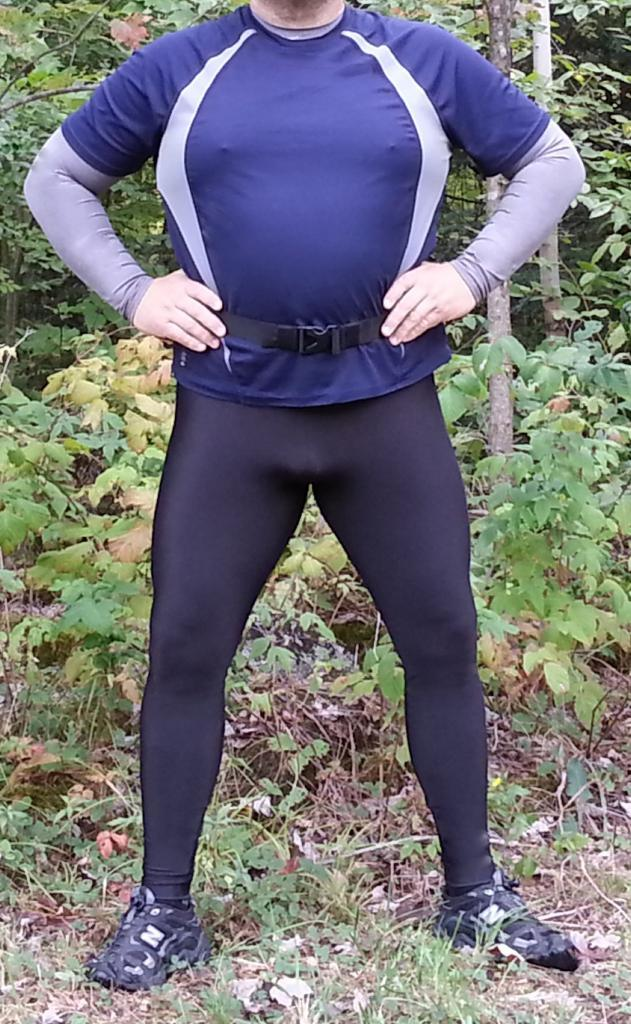What is the main subject of the image? There is a person standing in the image. Can you describe the person's attire? The person is wearing a blue and black color dress. What can be seen in the background of the image? There are plants in the background of the image. What is the color of the plants? The plants are green in color. What type of skate is the person using in the image? There is no skate present in the image; the person is simply standing. Can you tell me how many actors are in the image? There is no actor present in the image; it features a person standing. 